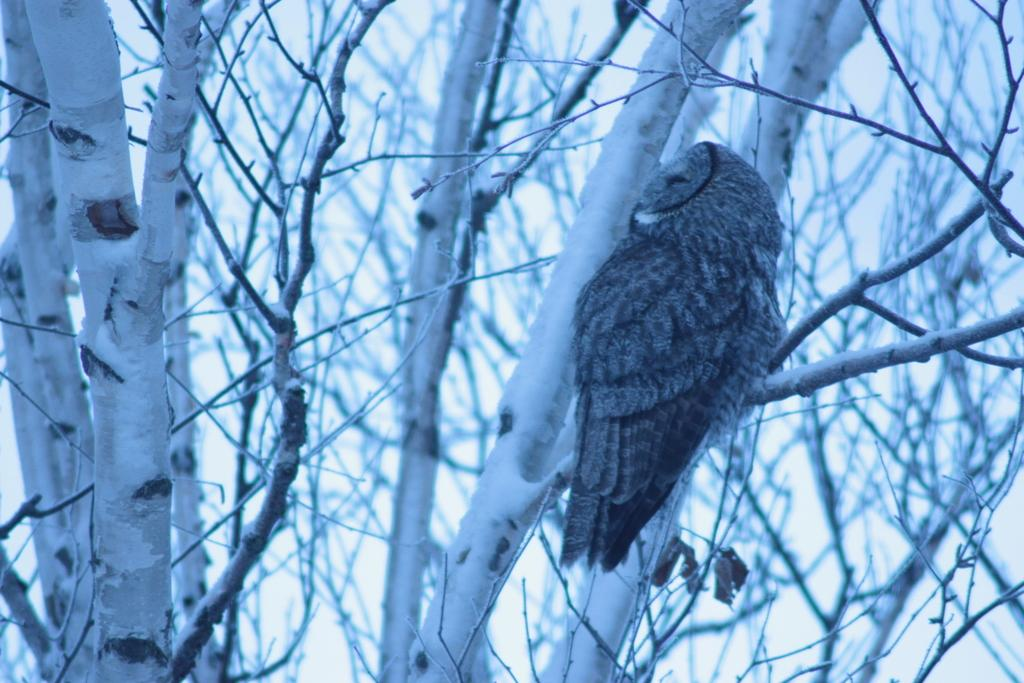What animal is featured in the image? There is an owl in the image. Where is the owl located? The owl is sitting on a tree branch. What part of the tree can be seen in the image? Tree trunks are visible in the image. Can you determine the time of day the image was taken? The image was likely taken during the day, as there is sufficient light to see the owl and tree trunks clearly. What song is the owl singing in the image? There is no indication that the owl is singing a song in the image. Owls do not sing songs like humans do. 